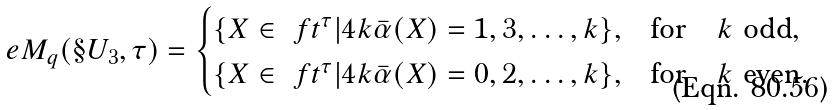Convert formula to latex. <formula><loc_0><loc_0><loc_500><loc_500>\ e M _ { q } ( \S U _ { 3 } , \tau ) = \begin{cases} \{ X \in \ f t ^ { \tau } | 4 k \bar { \alpha } ( X ) = 1 , 3 , \dots , k \} , & \text {for} \quad k \ \text {odd} , \\ \{ X \in \ f t ^ { \tau } | 4 k \bar { \alpha } ( X ) = 0 , 2 , \dots , k \} , & \text {for} \quad k \ \text {even} . \end{cases}</formula> 